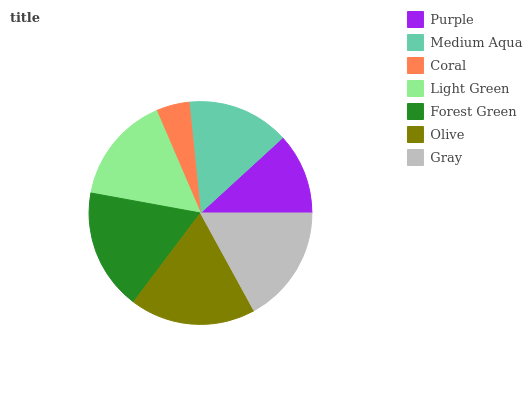Is Coral the minimum?
Answer yes or no. Yes. Is Olive the maximum?
Answer yes or no. Yes. Is Medium Aqua the minimum?
Answer yes or no. No. Is Medium Aqua the maximum?
Answer yes or no. No. Is Medium Aqua greater than Purple?
Answer yes or no. Yes. Is Purple less than Medium Aqua?
Answer yes or no. Yes. Is Purple greater than Medium Aqua?
Answer yes or no. No. Is Medium Aqua less than Purple?
Answer yes or no. No. Is Light Green the high median?
Answer yes or no. Yes. Is Light Green the low median?
Answer yes or no. Yes. Is Medium Aqua the high median?
Answer yes or no. No. Is Medium Aqua the low median?
Answer yes or no. No. 